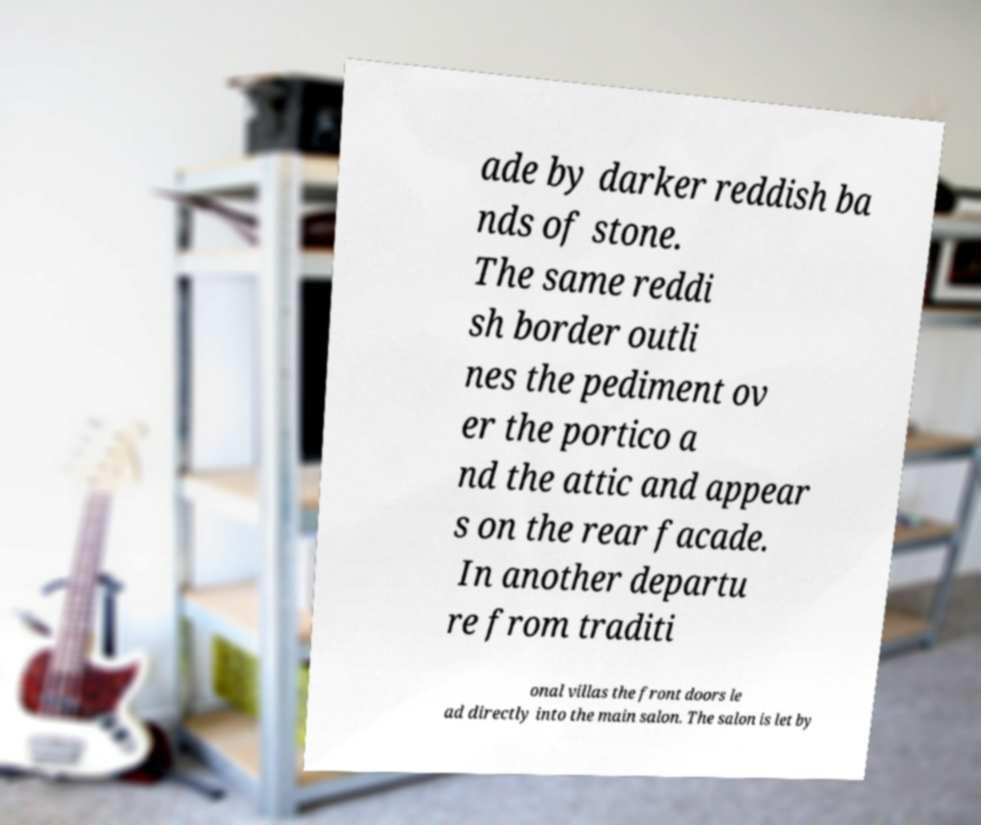I need the written content from this picture converted into text. Can you do that? ade by darker reddish ba nds of stone. The same reddi sh border outli nes the pediment ov er the portico a nd the attic and appear s on the rear facade. In another departu re from traditi onal villas the front doors le ad directly into the main salon. The salon is let by 